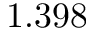<formula> <loc_0><loc_0><loc_500><loc_500>1 . 3 9 8</formula> 